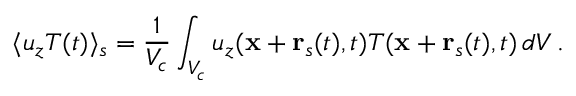<formula> <loc_0><loc_0><loc_500><loc_500>\langle u _ { z } T ( t ) \rangle _ { s } = \frac { 1 } { V _ { c } } \int _ { V _ { c } } u _ { z } ( { x } + { r } _ { s } ( t ) , t ) T ( { x } + { r } _ { s } ( t ) , t ) \, d V \, .</formula> 